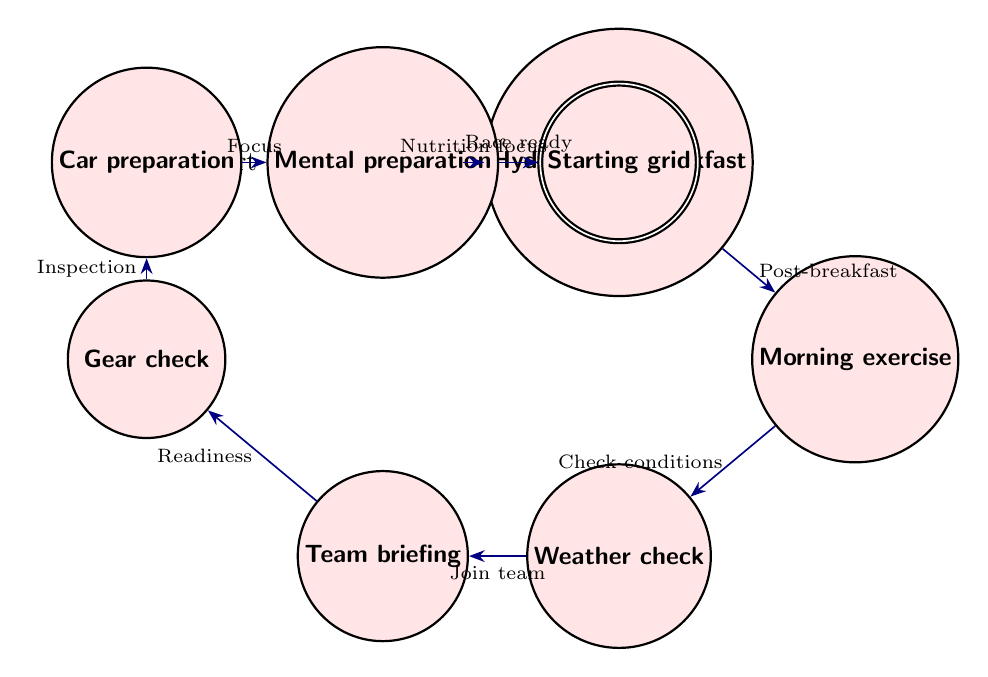What is the first state in the routine? The first state listed in the diagram is "Wake_up," which indicates that it is the initial action a driver takes in the morning routine.
Answer: Wake up How many states are there in total? By counting the states listed in the diagram, we determine there are a total of nine distinct states.
Answer: Nine What follows 'Team briefing' in the routine? Observing the transitions in the diagram, 'Team briefing' leads to 'Gear check' as the next state in the sequence.
Answer: Gear check What is the final state in the race day morning routine? The last state mentioned is 'Starting grid,' which indicates it is the final preparatory step before the race.
Answer: Starting grid What is the relationship between 'Car preparation' and 'Mental preparation'? The relationship is a direct transition; after 'Car preparation,' the driver moves to 'Mental preparation,' indicating a sequential workflow.
Answer: Direct transition What action is taken after 'Morning exercise'? The action taken after 'Morning exercise' is 'Weather check,' which is the next state in the sequence of the routine.
Answer: Weather check What is the connection between 'Hydration and breakfast' and 'Morning exercise'? The connection shows that after completing 'Hydration and breakfast,' the driver proceeds directly to 'Morning exercise,' indicating a planned flow in the morning preparation.
Answer: Direct connection Which state focuses on the car's mechanical systems? The state that emphasizes checking the car's mechanical systems is 'Car preparation,' where the driver inspects and confirms operations.
Answer: Car preparation What do drivers do as they prepare mentally before the race? In preparation for the race, drivers engage in 'Mental preparation,' focusing on visualizing the race ahead.
Answer: Mental preparation 